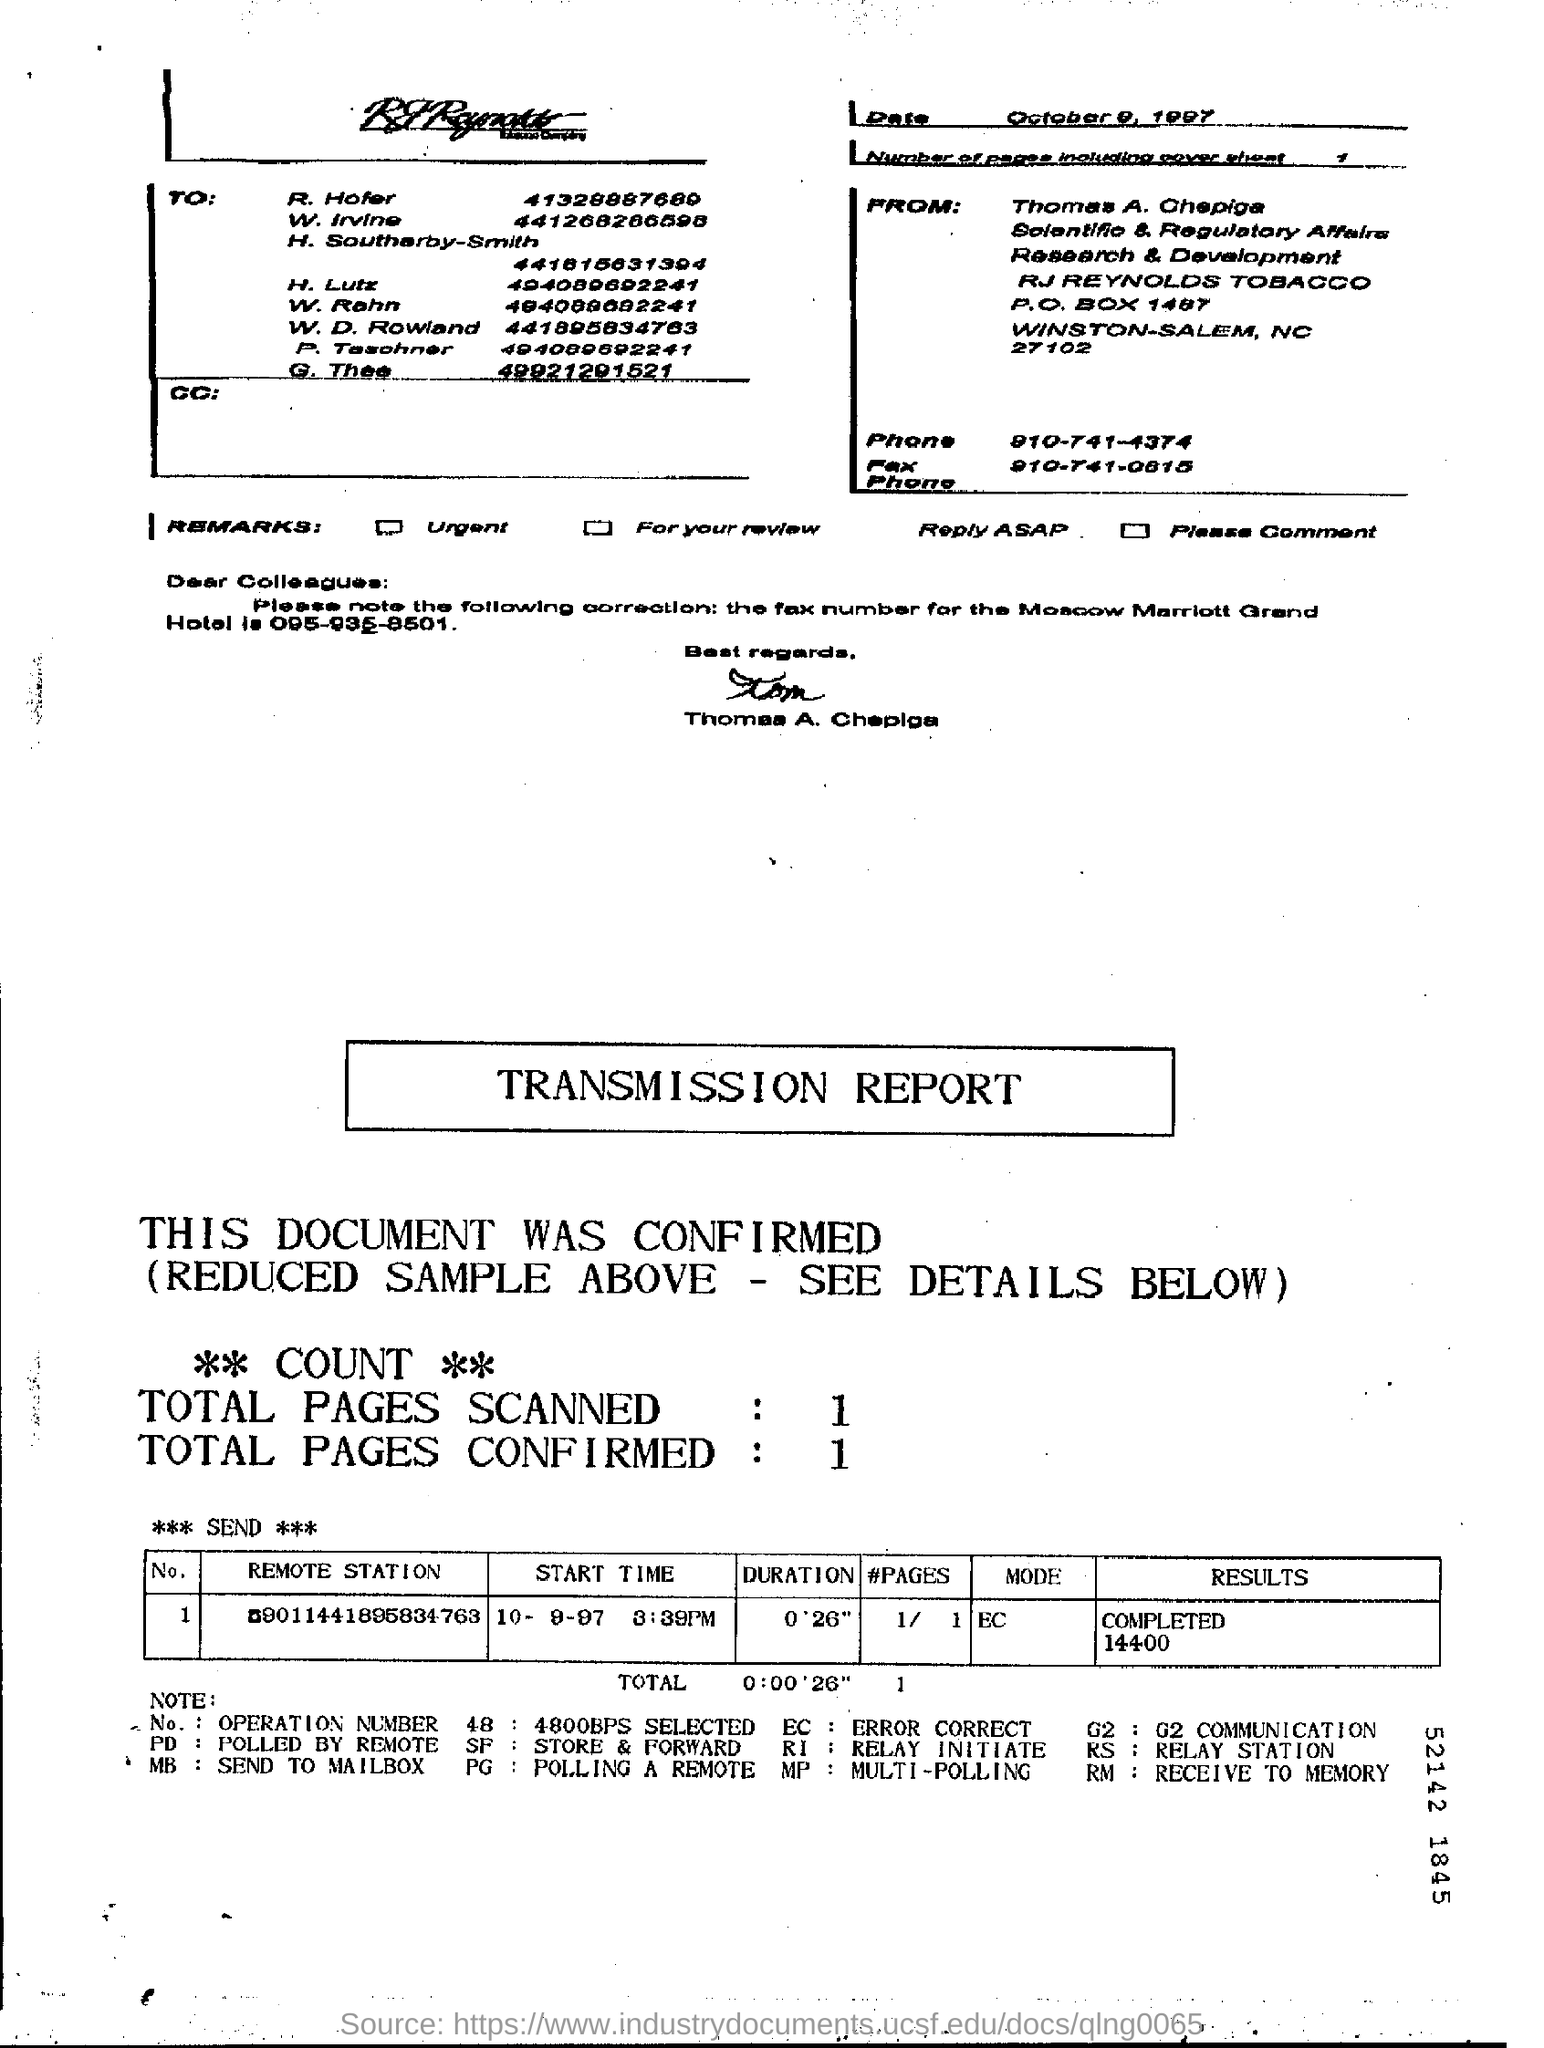What is the "Duration"?
Provide a short and direct response. 0'26". What are the Total Pages Scanned?
Keep it short and to the point. 1. What are the Total Pages Confirmed?
Offer a very short reply. 1. 